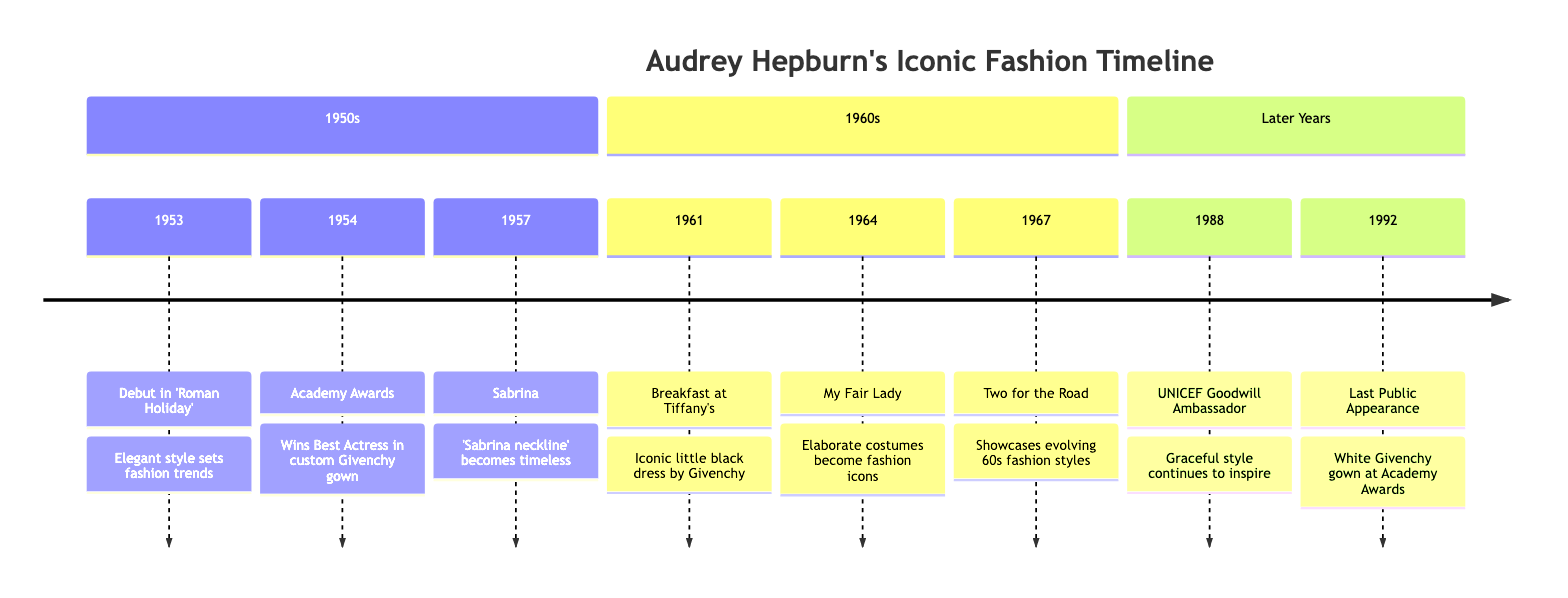What year did Audrey Hepburn debut in 'Roman Holiday'? The diagram indicates that Audrey Hepburn's debut in 'Roman Holiday' occurred in 1953, as stated right next to the specific event node.
Answer: 1953 Which designer created the gown Audrey wore at the 1954 Academy Awards? The diagram shows that the gown Audrey wore for the 1954 Academy Awards was custom designed by Givenchy, which is mentioned in the description related to that year.
Answer: Givenchy How many iconic fashion events are listed in the timeline? By counting the events noted in the diagram, which are 8 distinctive fashion moments attended by Audrey Hepburn, the total number of events can be determined.
Answer: 8 In which film did Audrey Hepburn wear the iconic little black dress? The timeline specifies that Audrey Hepburn wore the iconic little black dress in 'Breakfast at Tiffany's' in 1961, which is outlined under that year in the diagram.
Answer: Breakfast at Tiffany’s What role did Audrey Hepburn take on in 1988? According to the timeline, in 1988, Audrey Hepburn became a UNICEF Goodwill Ambassador, which is explicitly mentioned for that event in the diagram.
Answer: UNICEF Goodwill Ambassador Which fashion statement originated from the movie 'Sabrina'? The diagram states that 'Sabrina' led to the creation of the 'Sabrina neckline', specifically mentioned in the description for the year 1957.
Answer: Sabrina neckline In what year did Audrey Hepburn make her last public appearance? The timeline indicates that Audrey Hepburn made her last public appearance in 1992, as detailed in the last section of the diagram.
Answer: 1992 Which movie features elaborate costumes that became fashion icons? The event described for the year 1964 identifies 'My Fair Lady' as the movie where Audrey starred and wore elaborate costumes that turned into fashion icons.
Answer: My Fair Lady 